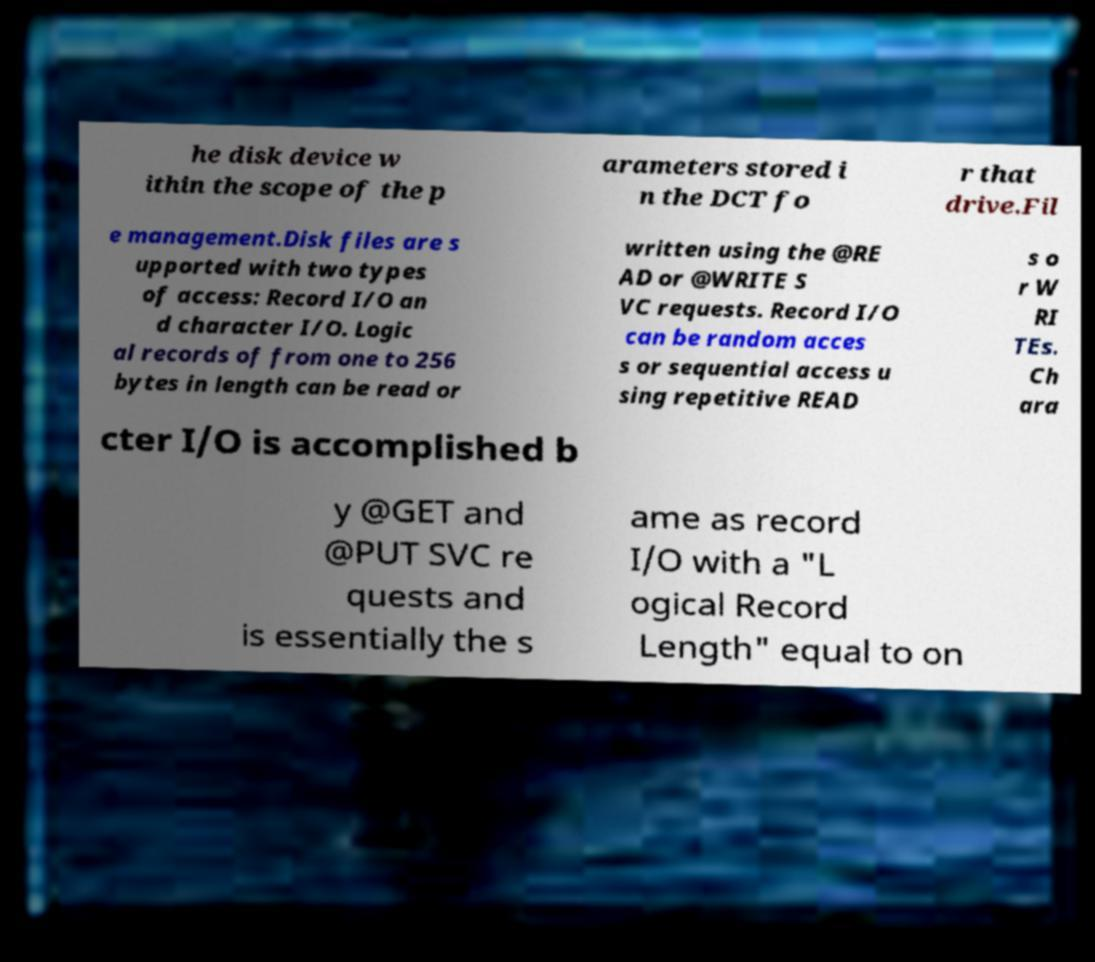Please identify and transcribe the text found in this image. he disk device w ithin the scope of the p arameters stored i n the DCT fo r that drive.Fil e management.Disk files are s upported with two types of access: Record I/O an d character I/O. Logic al records of from one to 256 bytes in length can be read or written using the @RE AD or @WRITE S VC requests. Record I/O can be random acces s or sequential access u sing repetitive READ s o r W RI TEs. Ch ara cter I/O is accomplished b y @GET and @PUT SVC re quests and is essentially the s ame as record I/O with a "L ogical Record Length" equal to on 